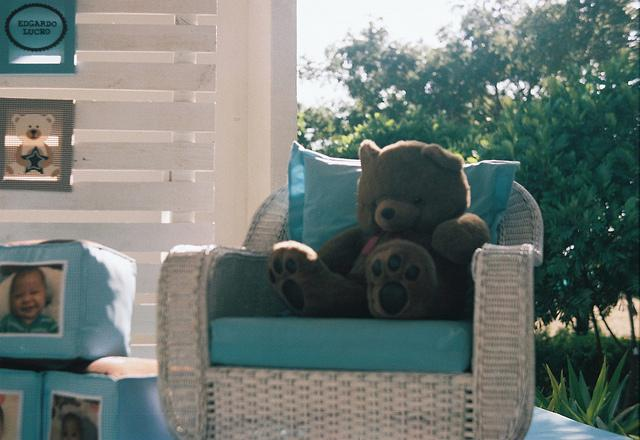How did the bear get there?

Choices:
A) fell
B) blew there
C) climbed up
D) placed there placed there 